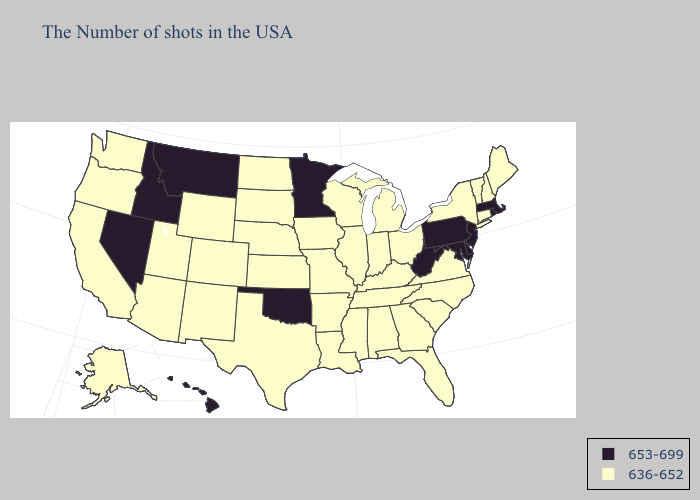Does North Dakota have the lowest value in the MidWest?
Give a very brief answer. Yes. Among the states that border Mississippi , which have the lowest value?
Concise answer only. Alabama, Tennessee, Louisiana, Arkansas. What is the lowest value in the South?
Give a very brief answer. 636-652. What is the highest value in states that border Minnesota?
Keep it brief. 636-652. What is the lowest value in the South?
Answer briefly. 636-652. Does Nebraska have a lower value than West Virginia?
Quick response, please. Yes. What is the highest value in the USA?
Answer briefly. 653-699. What is the value of Maine?
Short answer required. 636-652. What is the highest value in the West ?
Keep it brief. 653-699. What is the highest value in states that border Nebraska?
Be succinct. 636-652. Is the legend a continuous bar?
Give a very brief answer. No. What is the value of Oregon?
Write a very short answer. 636-652. What is the value of Nevada?
Short answer required. 653-699. What is the value of North Carolina?
Write a very short answer. 636-652. What is the value of Oregon?
Answer briefly. 636-652. 